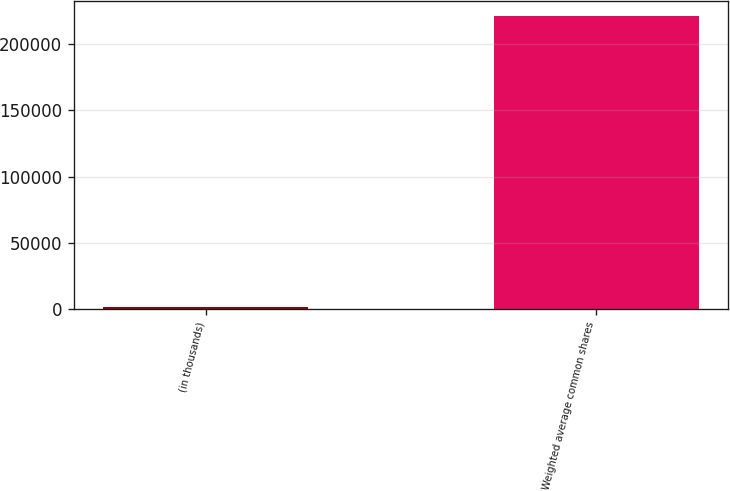Convert chart. <chart><loc_0><loc_0><loc_500><loc_500><bar_chart><fcel>(in thousands)<fcel>Weighted average common shares<nl><fcel>2011<fcel>221237<nl></chart> 